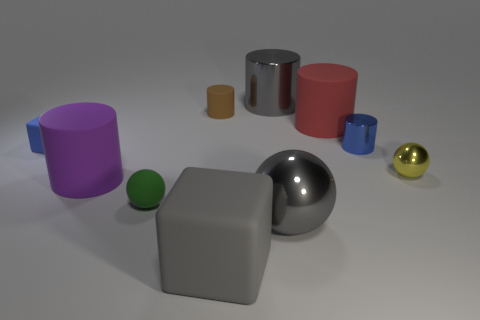Subtract all large spheres. How many spheres are left? 2 Subtract all blue cylinders. How many cylinders are left? 4 Subtract all spheres. How many objects are left? 7 Subtract 3 spheres. How many spheres are left? 0 Subtract all purple cylinders. Subtract all purple blocks. How many cylinders are left? 4 Subtract all tiny blue cylinders. Subtract all large purple rubber cylinders. How many objects are left? 8 Add 4 small blue metal cylinders. How many small blue metal cylinders are left? 5 Add 3 tiny gray shiny cubes. How many tiny gray shiny cubes exist? 3 Subtract 1 purple cylinders. How many objects are left? 9 